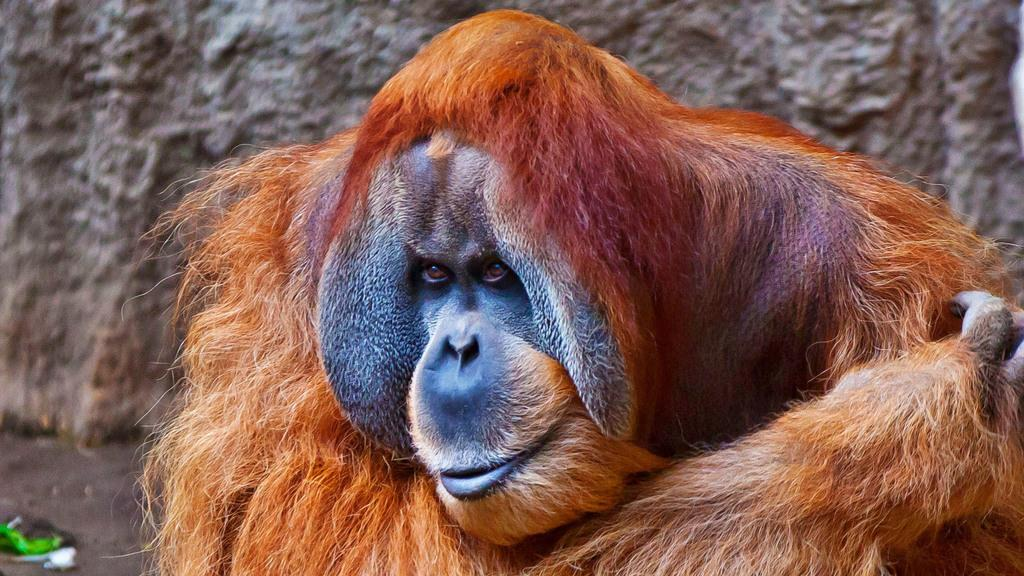What type of animal is in the image? There is a chimpanzee in the image. What can be seen in the background of the image? There is a rock in the background of the image. What is visible at the bottom of the image? There is ground visible at the bottom of the image. How many chairs are present in the image? There are no chairs visible in the image. What type of secretary is working with the chimpanzee in the image? There is no secretary present in the image; it only features a chimpanzee. 